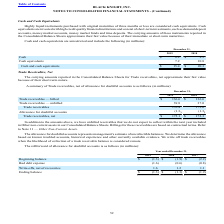According to Black Knight Financial Services's financial document, What was considered by the company to be cash equivalents? Highly liquid instruments purchased with original maturities of three months or less. The document states: "Highly liquid instruments purchased with original maturities of three months or less are considered cash equivalents. Cash..." Also, Which years does the table provide information for the company's Cash and cash equivalents are unrestricted? The document shows two values: 2019 and 2018. From the document: "2019 2018 2019 2018..." Also, What was the total cash and cash equivalents in 2018? According to the financial document, 20.3 (in millions). The relevant text states: "Cash and cash equivalents $ 15.4 $ 20.3..." Also, can you calculate: What was the change in cash equivalents between 2018 and 2019? Based on the calculation: 7.2-10.8, the result is -3.6 (in millions). This is based on the information: "Cash equivalents 7.2 10.8 Cash equivalents 7.2 10.8..." The key data points involved are: 10.8, 7.2. Also, can you calculate: What was the change in Cash between 2018 and 2019? Based on the calculation: 8.2-9.5, the result is -1.3 (in millions). This is based on the information: "Cash $ 8.2 $ 9.5 Cash $ 8.2 $ 9.5..." The key data points involved are: 8.2, 9.5. Also, can you calculate: What was the percentage change in Cash and cash equivalents between 2018 and 2019? To answer this question, I need to perform calculations using the financial data. The calculation is: (15.4-20.3)/20.3, which equals -24.14 (percentage). This is based on the information: "Cash and cash equivalents $ 15.4 $ 20.3 Cash and cash equivalents $ 15.4 $ 20.3..." The key data points involved are: 15.4, 20.3. 